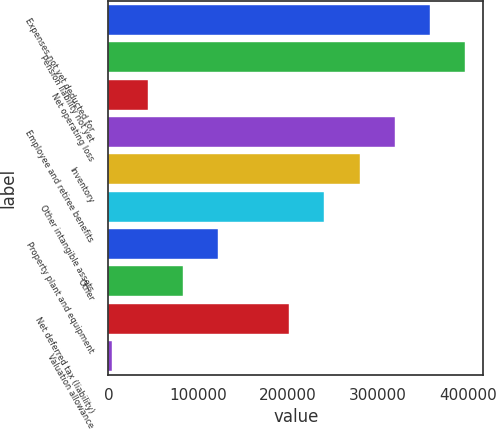Convert chart. <chart><loc_0><loc_0><loc_500><loc_500><bar_chart><fcel>Expenses not yet deducted for<fcel>Pension liability not yet<fcel>Net operating loss<fcel>Employee and retiree benefits<fcel>Inventory<fcel>Other intangible assets<fcel>Property plant and equipment<fcel>Other<fcel>Net deferred tax (liability)<fcel>Valuation allowance<nl><fcel>358092<fcel>397391<fcel>43703.6<fcel>318794<fcel>279495<fcel>240197<fcel>122301<fcel>83002.2<fcel>200898<fcel>4405<nl></chart> 